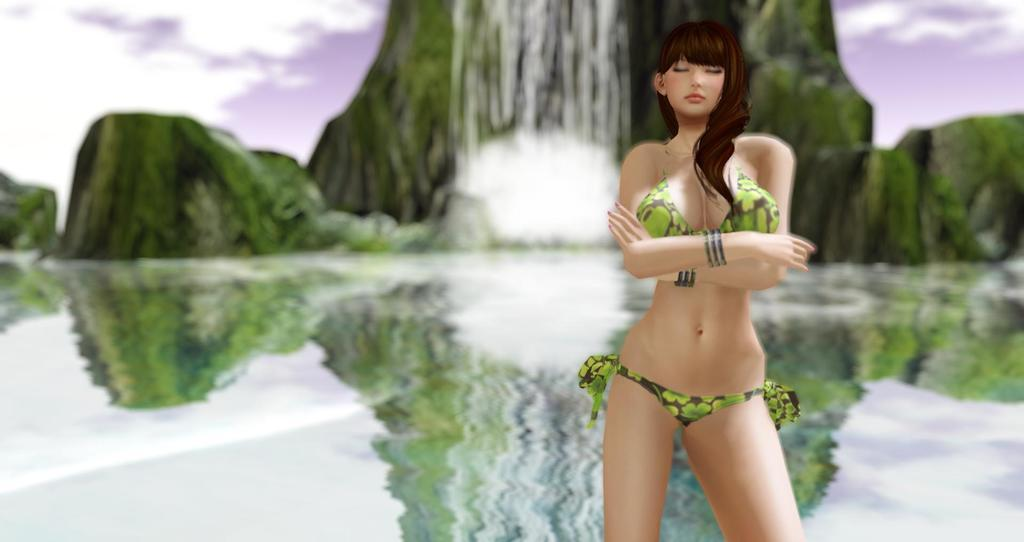What type of image is being described? The image is an animation. Can you describe the main subject in the image? There is a lady standing in the image. How would you describe the background of the image? The background appears blurred. What natural elements can be seen in the image? There is water and a sky visible in the image. Are there any geographical features present in the image? Yes, there are hills with a waterfall in the image. How many rabbits are hopping around in the image? There are no rabbits present in the image. What type of health benefits does the waterfall provide in the image? The image does not provide information about any health benefits associated with the waterfall. 